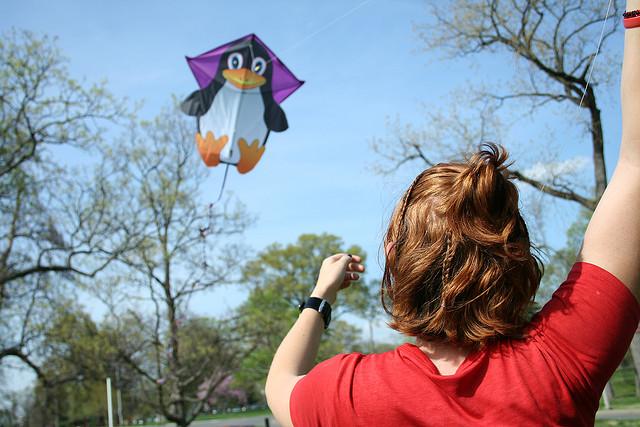Does the girl have braids in her hair?
Quick response, please. Yes. What is the shape of the kite?
Be succinct. Penguin. What is in the sky?
Short answer required. Kite. 